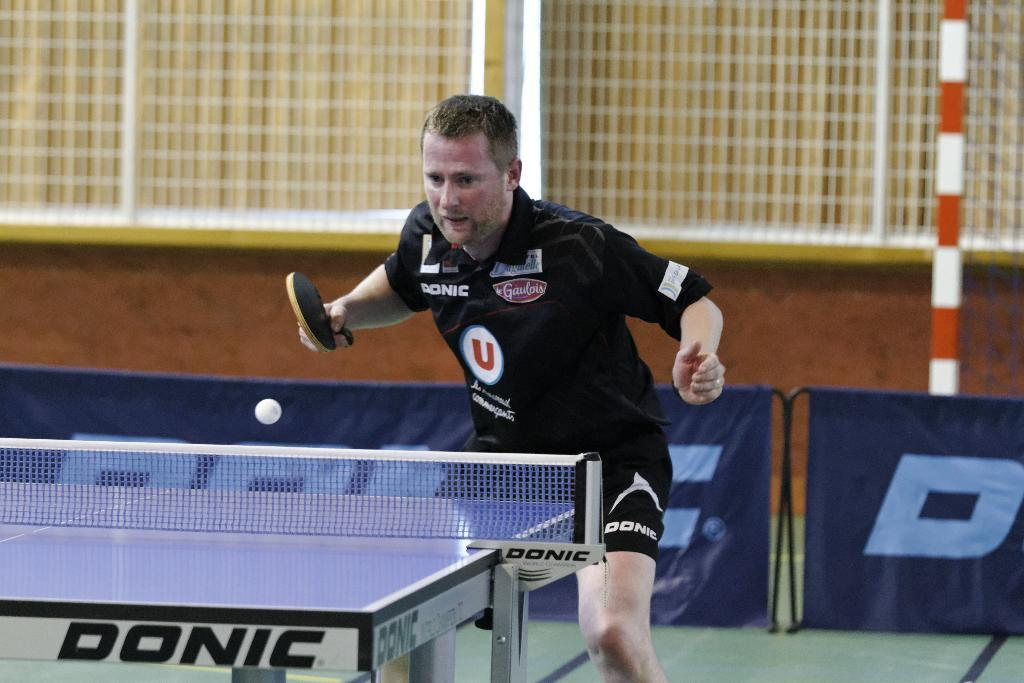Who is the main subject in the image? There is a man in the image. What is the man doing in the image? The man is playing table tennis. What object is the man holding in his hand? The man is holding a bat in his hand. How many beggars can be seen in the image? There are no beggars present in the image. What is the health condition of the man's hands in the image? There is no information about the man's hands or their health condition in the image. 